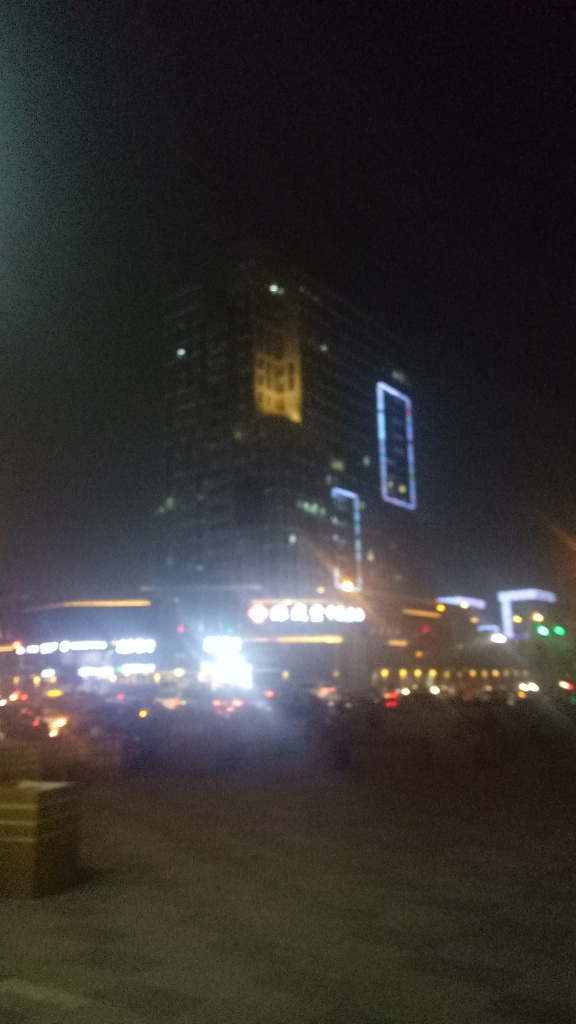What time of day does this image seem to depict and why? The image seems to depict nighttime, which is evident from the darkness of the sky and the prominence of artificial lighting from the buildings and street lights. The various lighting suggests the photo was taken when natural light was insufficient, hence during night hours. 